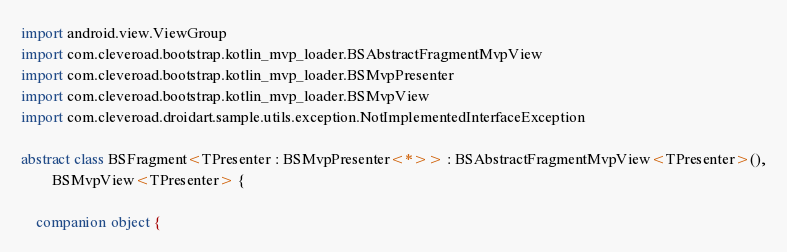Convert code to text. <code><loc_0><loc_0><loc_500><loc_500><_Kotlin_>import android.view.ViewGroup
import com.cleveroad.bootstrap.kotlin_mvp_loader.BSAbstractFragmentMvpView
import com.cleveroad.bootstrap.kotlin_mvp_loader.BSMvpPresenter
import com.cleveroad.bootstrap.kotlin_mvp_loader.BSMvpView
import com.cleveroad.droidart.sample.utils.exception.NotImplementedInterfaceException

abstract class BSFragment<TPresenter : BSMvpPresenter<*>> : BSAbstractFragmentMvpView<TPresenter>(),
        BSMvpView<TPresenter> {

    companion object {</code> 